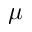Convert formula to latex. <formula><loc_0><loc_0><loc_500><loc_500>\mu</formula> 